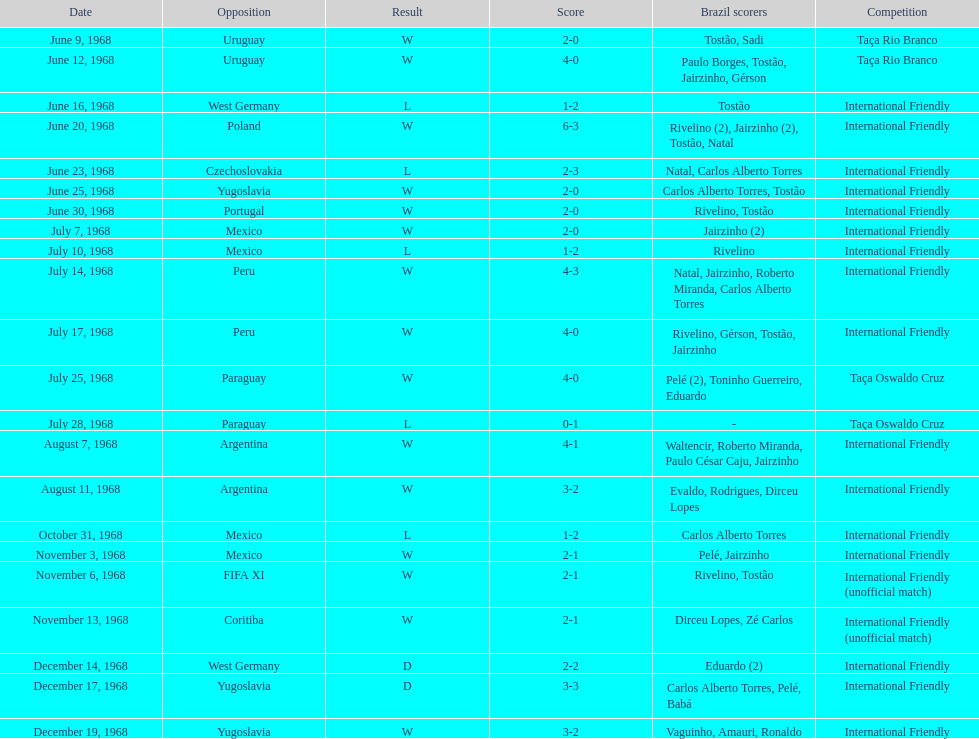What is the maximum score ever attained by the national team of brazil? 6. 